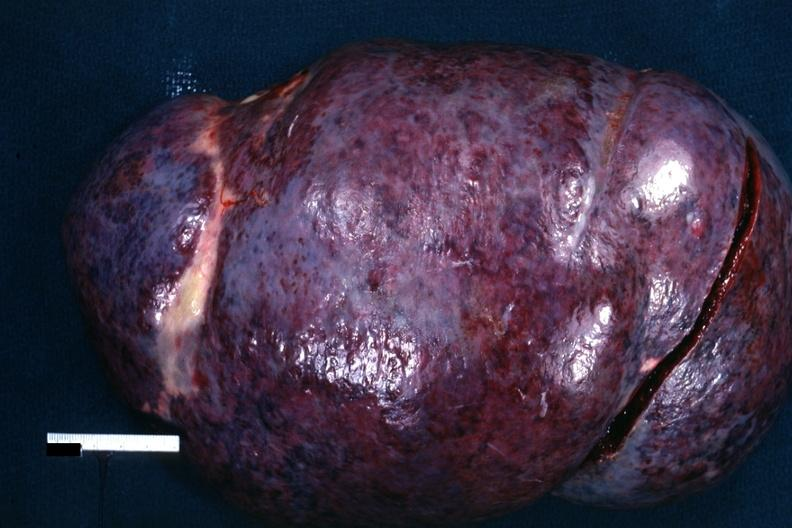s chronic lymphocytic leukemia present?
Answer the question using a single word or phrase. Yes 